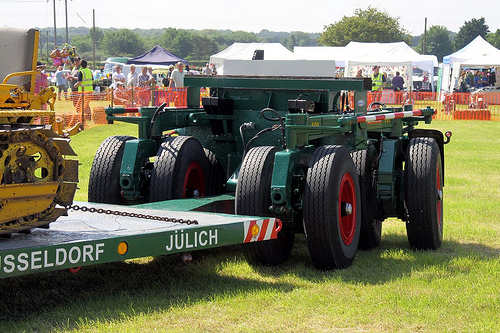<image>
Is there a tire next to the tire? Yes. The tire is positioned adjacent to the tire, located nearby in the same general area. 